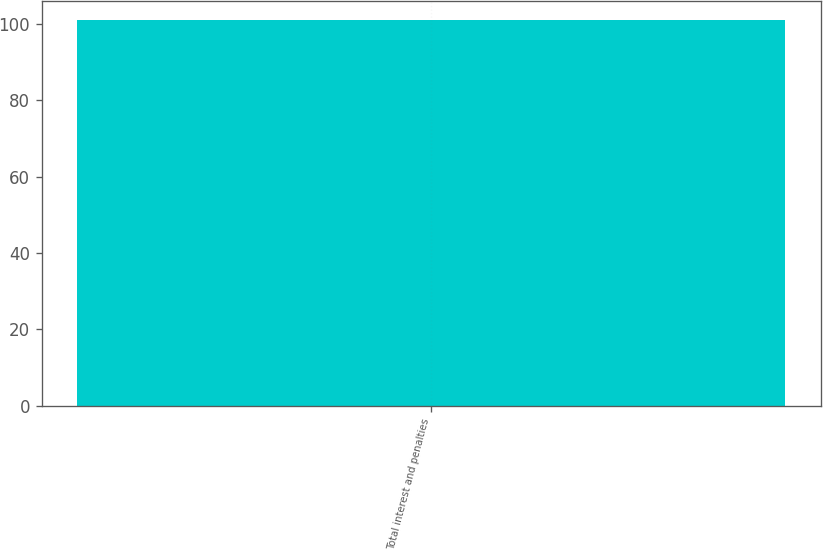Convert chart to OTSL. <chart><loc_0><loc_0><loc_500><loc_500><bar_chart><fcel>Total interest and penalties<nl><fcel>101<nl></chart> 